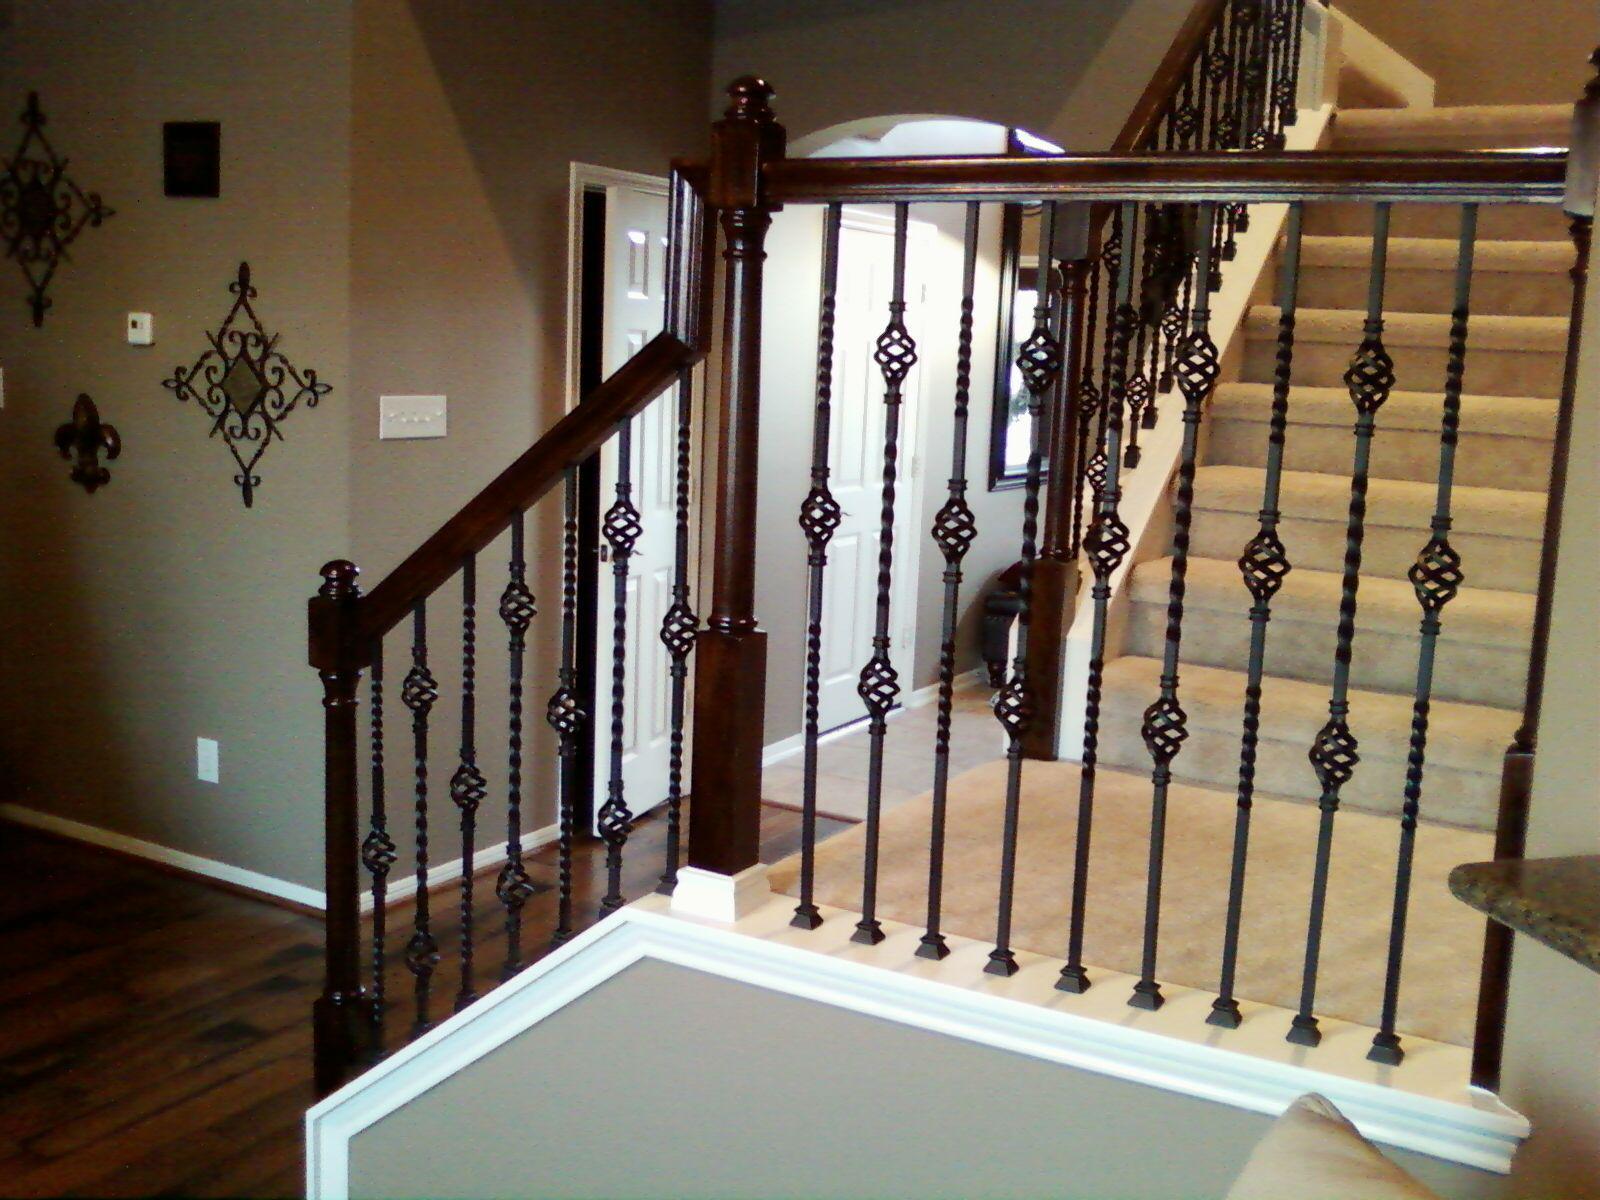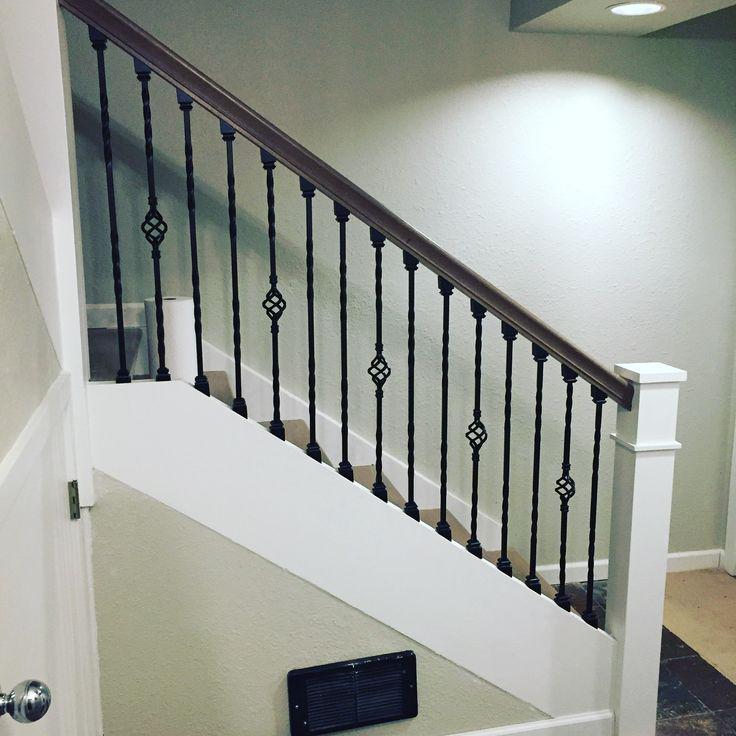The first image is the image on the left, the second image is the image on the right. Evaluate the accuracy of this statement regarding the images: "Each image features a staircase that ascends diagonally from the lower left and has wrought iron bars with some type of decorative embellishment.". Is it true? Answer yes or no. No. The first image is the image on the left, the second image is the image on the right. Examine the images to the left and right. Is the description "Exactly one stairway changes directions." accurate? Answer yes or no. Yes. 